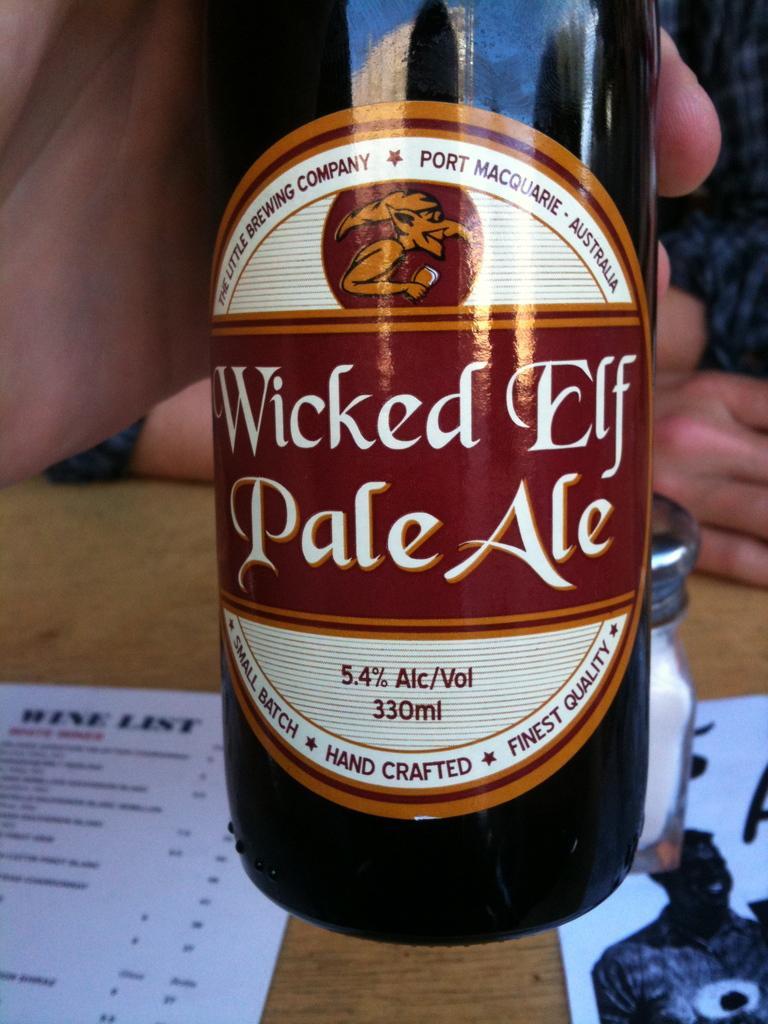Please provide a concise description of this image. In this picture we can see a person hand is holding a bottle, wooden surface with papers, jar on it and in the background we can see a person. 